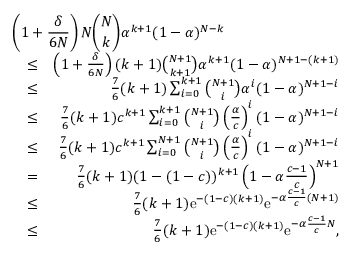<formula> <loc_0><loc_0><loc_500><loc_500>\begin{array} { r l r } { { \left ( 1 + \frac { \delta } { 6 N } \right ) N { \binom { N } { k } } \alpha ^ { k + 1 } ( 1 - \alpha ) ^ { N - k } } } \\ & { \leq } & { \left ( 1 + \frac { \delta } { 6 N } \right ) ( k + 1 ) { \binom { N + 1 } { k + 1 } } \alpha ^ { k + 1 } ( 1 - \alpha ) ^ { N + 1 - ( k + 1 ) } } \\ & { \leq } & { \frac { 7 } { 6 } ( k + 1 ) \sum _ { i = 0 } ^ { k + 1 } { \binom { N + 1 } { i } } \alpha ^ { i } ( 1 - \alpha ) ^ { N + 1 - i } } \\ & { \leq } & { \frac { 7 } { 6 } ( k + 1 ) c ^ { k + 1 } \sum _ { i = 0 } ^ { k + 1 } { \binom { N + 1 } { i } } \left ( \frac { \alpha } { c } \right ) ^ { i } ( 1 - \alpha ) ^ { N + 1 - i } } \\ & { \leq } & { \frac { 7 } { 6 } ( k + 1 ) c ^ { k + 1 } \sum _ { i = 0 } ^ { N + 1 } { \binom { N + 1 } { i } } \left ( \frac { \alpha } { c } \right ) ^ { i } ( 1 - \alpha ) ^ { N + 1 - i } } \\ & { = } & { \frac { 7 } { 6 } ( k + 1 ) ( 1 - ( 1 - c ) ) ^ { k + 1 } \left ( 1 - \alpha \frac { c - 1 } { c } \right ) ^ { N + 1 } } \\ & { \leq } & { \frac { 7 } { 6 } ( k + 1 ) e ^ { - ( 1 - c ) ( k + 1 ) } e ^ { - \alpha \frac { c - 1 } { c } ( N + 1 ) } } \\ & { \leq } & { \frac { 7 } { 6 } ( k + 1 ) e ^ { - ( 1 - c ) ( k + 1 ) } e ^ { - \alpha \frac { c - 1 } { c } N } , } \end{array}</formula> 